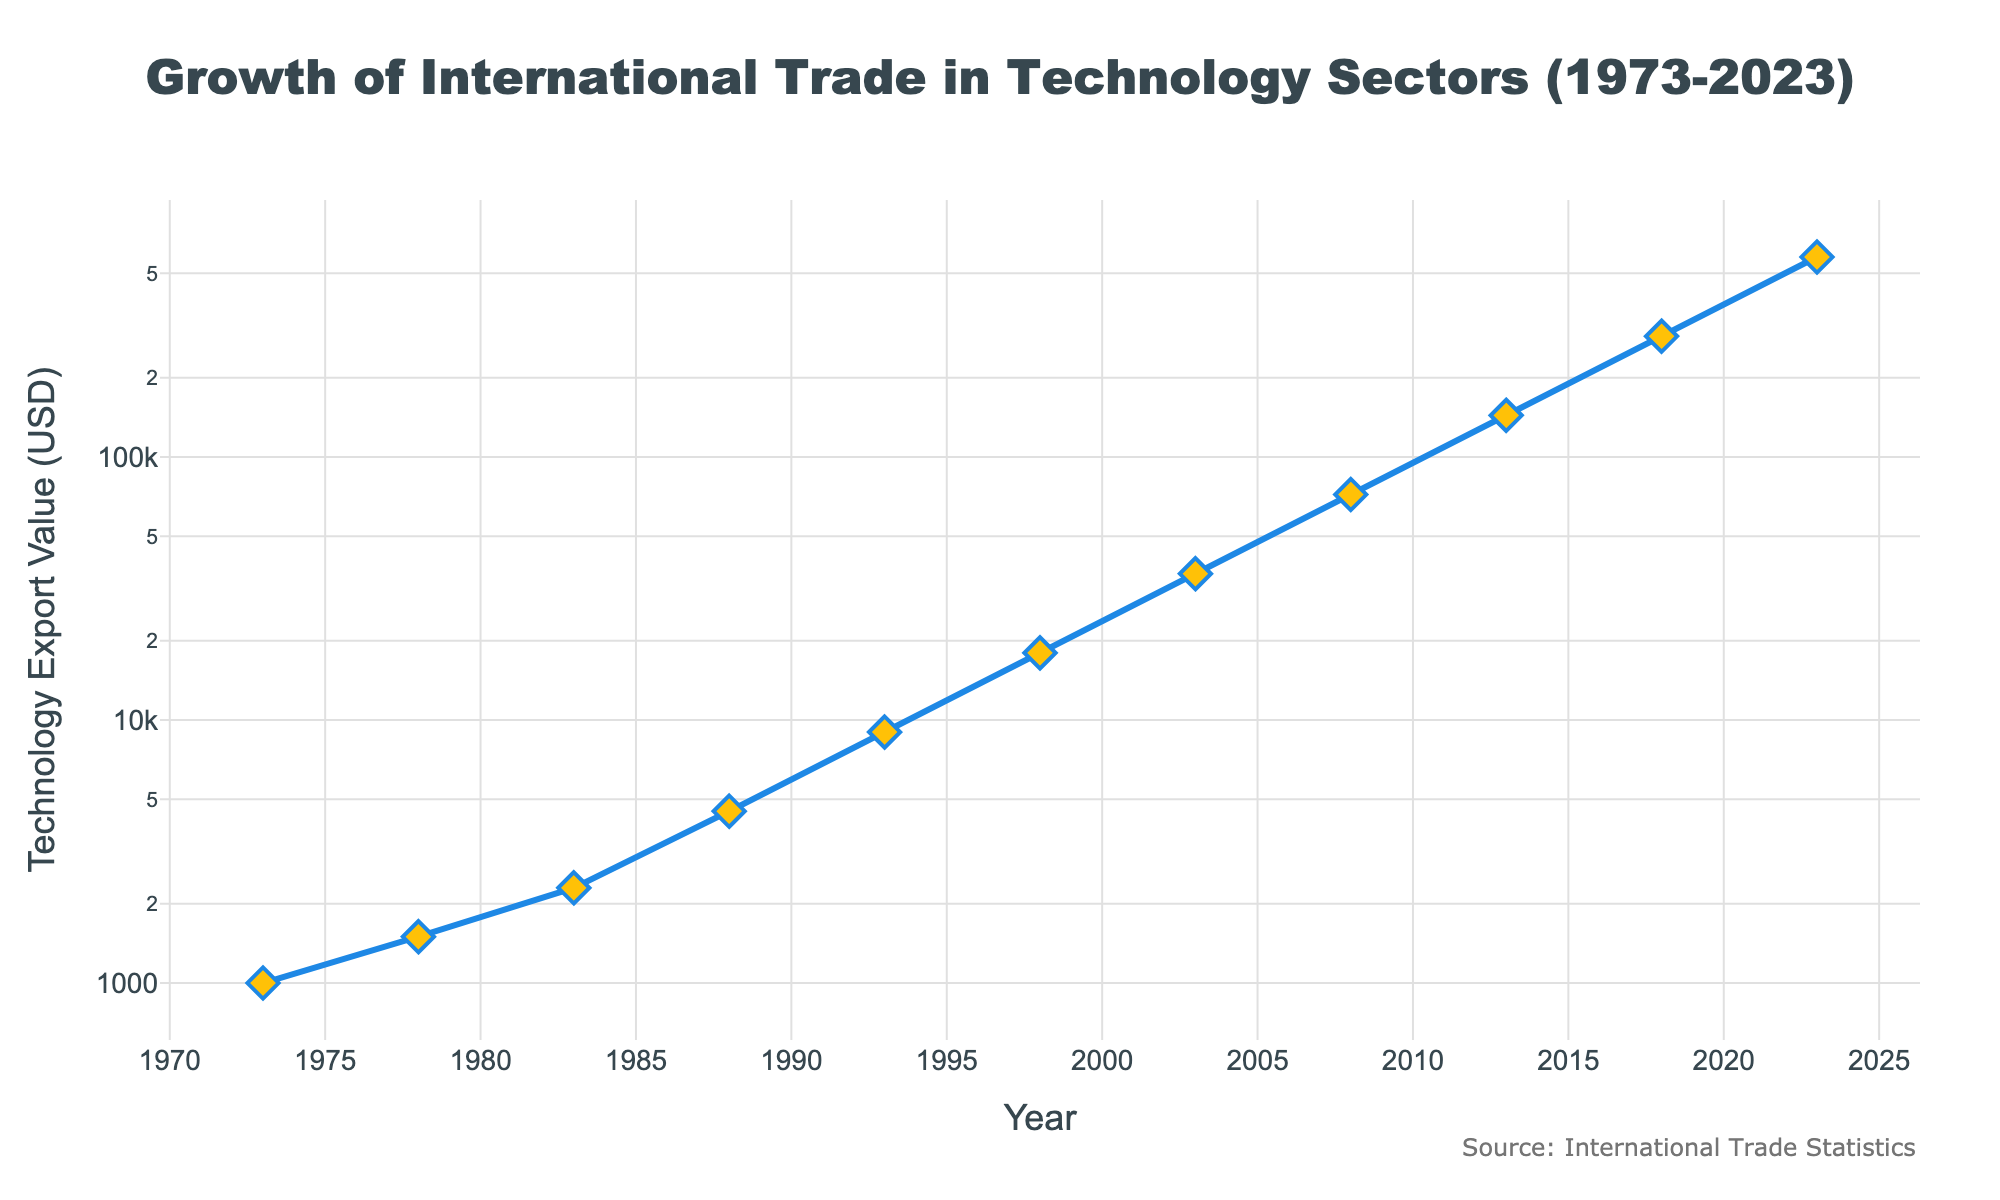What is the title of the plot? The title of the plot is at the top and is typically larger and bolder than the rest of the text. It provides an overall description of what the plot represents.
Answer: Growth of International Trade in Technology Sectors (1973-2023) What is the y-axis scale type of the figure? The type of scale used for the y-axis can be identified along the axis. It is specified within the layout settings in the figure description.
Answer: Logarithmic What is the color of the line representing Technology Export Value? The color of the line can be determined by visually inspecting the line on the plot. The color should stand out distinctly among other plot elements.
Answer: Blue In what year does the Technology Export Value reach approximately 100,000 USD? Locate the value on the y-axis (100,000 USD) and draw an imaginary horizontal line to intersect the curve. The corresponding year on the x-axis is the answer.
Answer: Around 2011-2012 Between which years does the Technology Export Value approximately double from about 1,000 to 2,000 USD? Identify the years when the curve roughly reaches 1,000 and 2,000 USD on the y-axis and refer to the x-axis for the corresponding years, then note the timespan.
Answer: Between 1973 and 1978 How many data points are represented in the plot? Count the number of markers on the plot, each representing one data point.
Answer: 11 Which period shows the highest rate of growth in Technology Export Value? Examine the steepness of the curve over different periods. The period with the steepest slope indicates the highest rate of growth.
Answer: Between 2018 and 2023 What is the difference in Technology Export Value between 1988 and 1993? Identify the values at 1988 and 1993 on the plot and subtract the earlier value from the later value.
Answer: 4500 USD By what factor did the Technology Export Value increase from 1973 to 2023? The increase factor can be calculated by dividing the value in 2023 by the value in 1973.
Answer: 576 What trend can be observed from the figure regarding the growth of international trade in technology sectors over the last 50 years? Observe the general direction and pattern of the trend line. If the curve is generally rising, it indicates a growth trend.
Answer: Increasing exponentially 